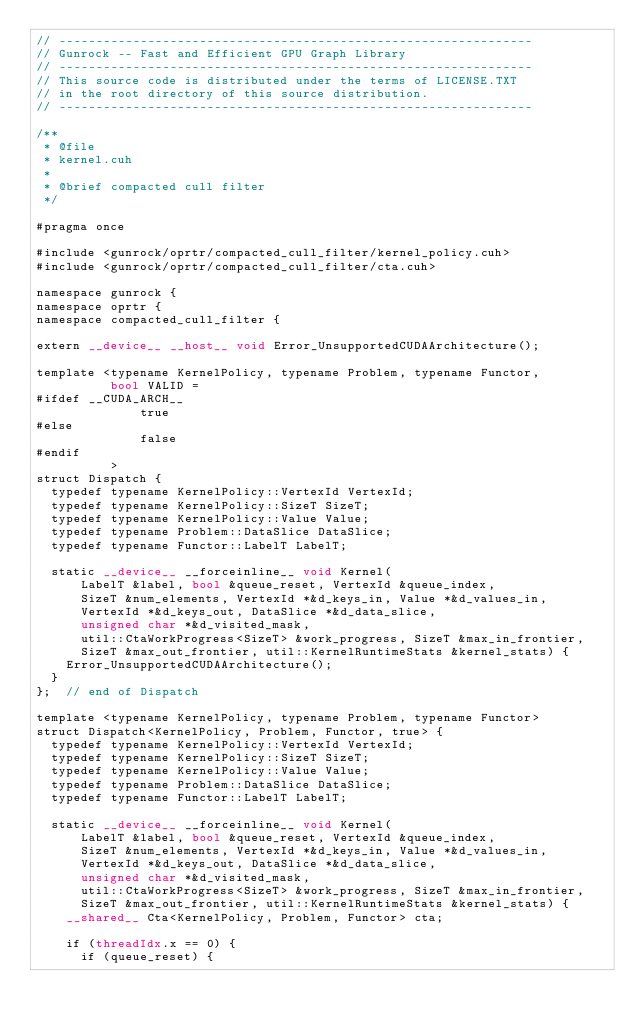Convert code to text. <code><loc_0><loc_0><loc_500><loc_500><_Cuda_>// ----------------------------------------------------------------
// Gunrock -- Fast and Efficient GPU Graph Library
// ----------------------------------------------------------------
// This source code is distributed under the terms of LICENSE.TXT
// in the root directory of this source distribution.
// ----------------------------------------------------------------

/**
 * @file
 * kernel.cuh
 *
 * @brief compacted cull filter
 */

#pragma once

#include <gunrock/oprtr/compacted_cull_filter/kernel_policy.cuh>
#include <gunrock/oprtr/compacted_cull_filter/cta.cuh>

namespace gunrock {
namespace oprtr {
namespace compacted_cull_filter {

extern __device__ __host__ void Error_UnsupportedCUDAArchitecture();

template <typename KernelPolicy, typename Problem, typename Functor,
          bool VALID = 
#ifdef __CUDA_ARCH__
              true
#else
              false
#endif
          >
struct Dispatch {
  typedef typename KernelPolicy::VertexId VertexId;
  typedef typename KernelPolicy::SizeT SizeT;
  typedef typename KernelPolicy::Value Value;
  typedef typename Problem::DataSlice DataSlice;
  typedef typename Functor::LabelT LabelT;

  static __device__ __forceinline__ void Kernel(
      LabelT &label, bool &queue_reset, VertexId &queue_index,
      SizeT &num_elements, VertexId *&d_keys_in, Value *&d_values_in,
      VertexId *&d_keys_out, DataSlice *&d_data_slice,
      unsigned char *&d_visited_mask,
      util::CtaWorkProgress<SizeT> &work_progress, SizeT &max_in_frontier,
      SizeT &max_out_frontier, util::KernelRuntimeStats &kernel_stats) {
    Error_UnsupportedCUDAArchitecture();
  }
};  // end of Dispatch

template <typename KernelPolicy, typename Problem, typename Functor>
struct Dispatch<KernelPolicy, Problem, Functor, true> {
  typedef typename KernelPolicy::VertexId VertexId;
  typedef typename KernelPolicy::SizeT SizeT;
  typedef typename KernelPolicy::Value Value;
  typedef typename Problem::DataSlice DataSlice;
  typedef typename Functor::LabelT LabelT;

  static __device__ __forceinline__ void Kernel(
      LabelT &label, bool &queue_reset, VertexId &queue_index,
      SizeT &num_elements, VertexId *&d_keys_in, Value *&d_values_in,
      VertexId *&d_keys_out, DataSlice *&d_data_slice,
      unsigned char *&d_visited_mask,
      util::CtaWorkProgress<SizeT> &work_progress, SizeT &max_in_frontier,
      SizeT &max_out_frontier, util::KernelRuntimeStats &kernel_stats) {
    __shared__ Cta<KernelPolicy, Problem, Functor> cta;

    if (threadIdx.x == 0) {
      if (queue_reset) {</code> 